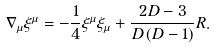<formula> <loc_0><loc_0><loc_500><loc_500>\nabla _ { \mu } \xi ^ { \mu } = - \frac { 1 } { 4 } \xi ^ { \mu } \xi _ { \mu } + \frac { 2 D - 3 } { D \left ( D - 1 \right ) } R .</formula> 